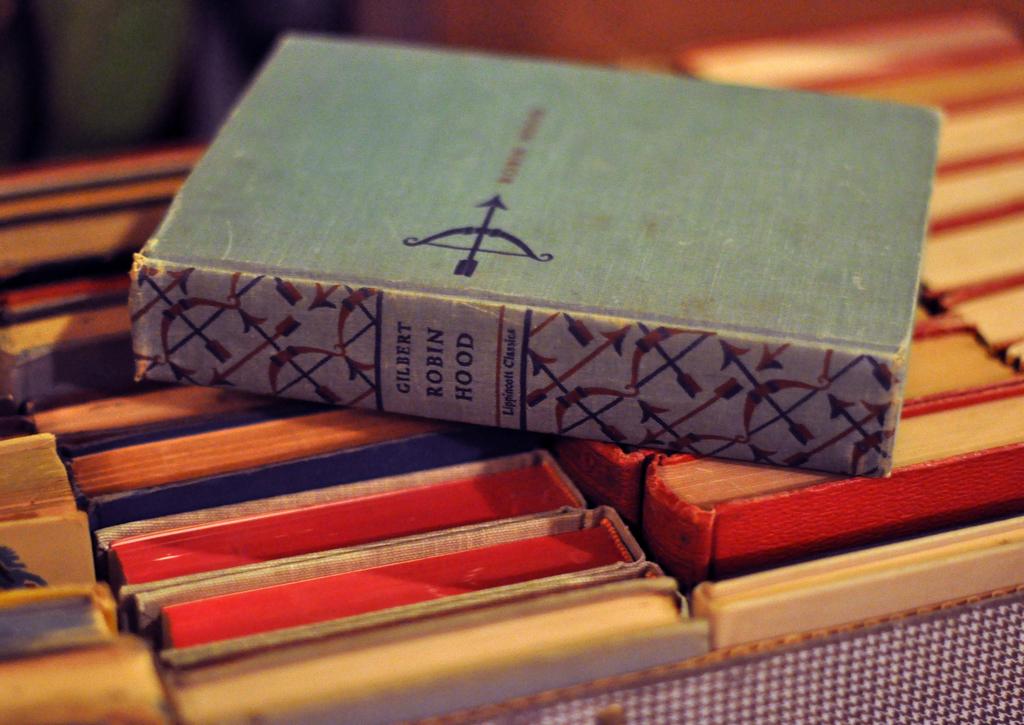What is the title of this book?
Offer a terse response. Robin hood. 